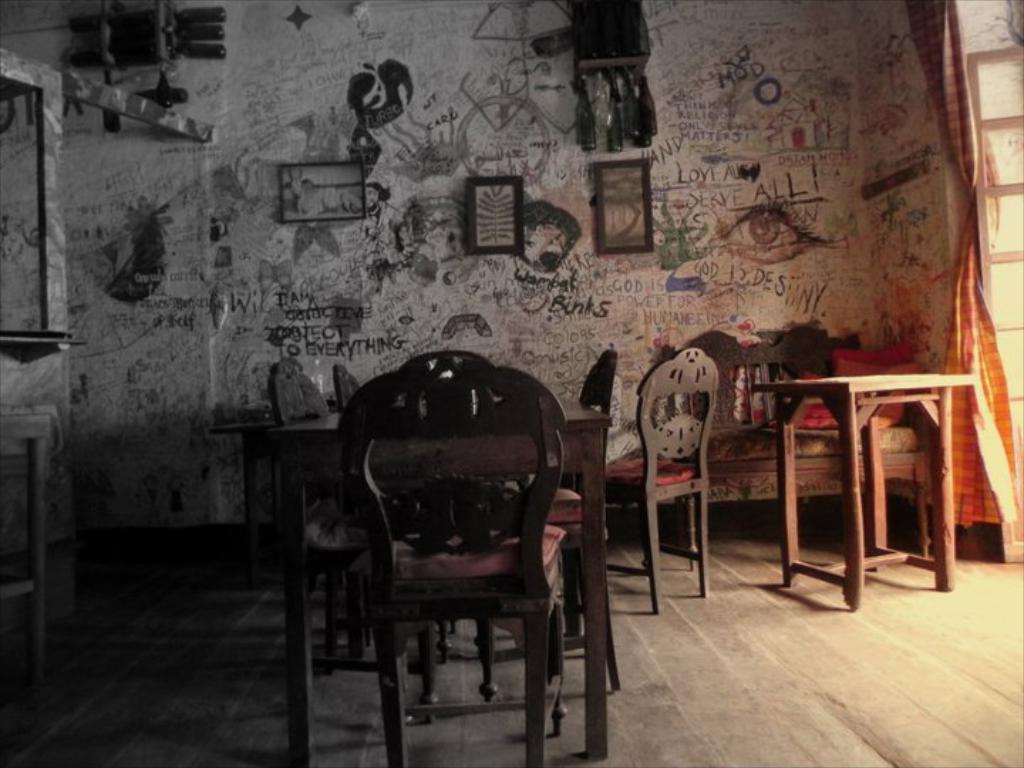Can you describe this image briefly? In this image there are chairs and tables on the floor. Right side there is a door. Behind there is a curtain. Background there is a wall having picture frames attached to it. There are bottles hanging from an object. There is some text and pictures painted on the wall. 